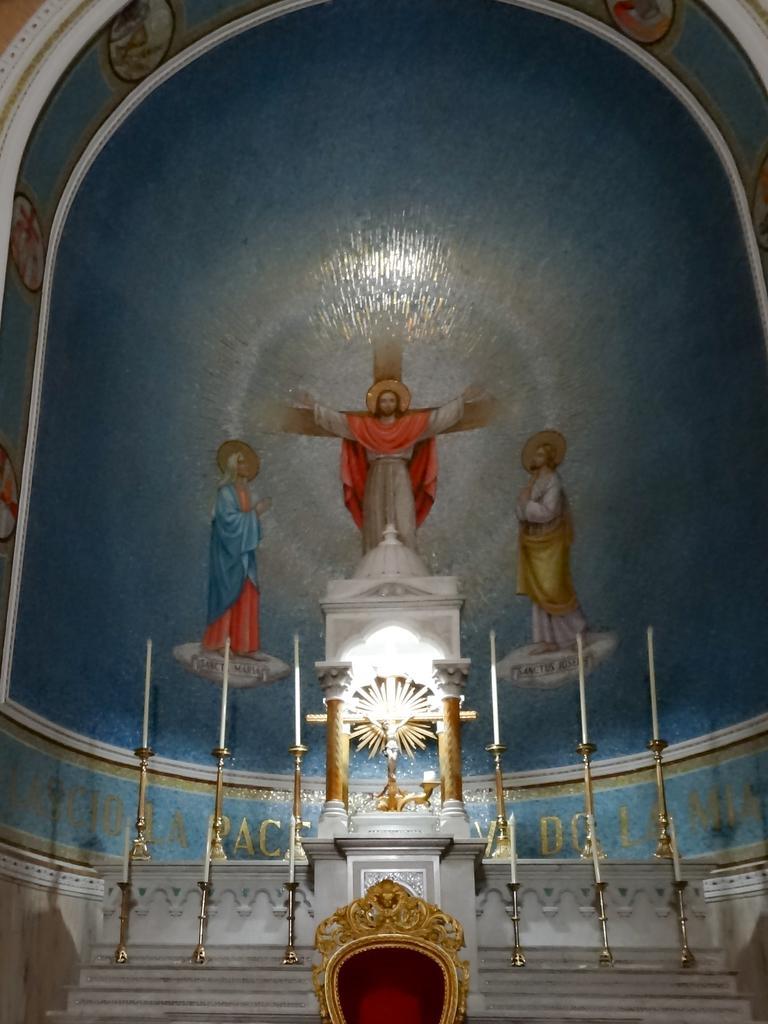Please provide a concise description of this image. In this picture we can see candles on stands, steps, pillars, statue and an object. In the background of the image we can see painting on the wall. 